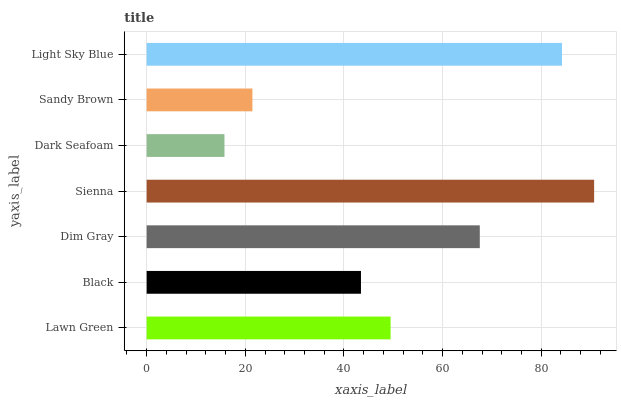Is Dark Seafoam the minimum?
Answer yes or no. Yes. Is Sienna the maximum?
Answer yes or no. Yes. Is Black the minimum?
Answer yes or no. No. Is Black the maximum?
Answer yes or no. No. Is Lawn Green greater than Black?
Answer yes or no. Yes. Is Black less than Lawn Green?
Answer yes or no. Yes. Is Black greater than Lawn Green?
Answer yes or no. No. Is Lawn Green less than Black?
Answer yes or no. No. Is Lawn Green the high median?
Answer yes or no. Yes. Is Lawn Green the low median?
Answer yes or no. Yes. Is Sienna the high median?
Answer yes or no. No. Is Dim Gray the low median?
Answer yes or no. No. 